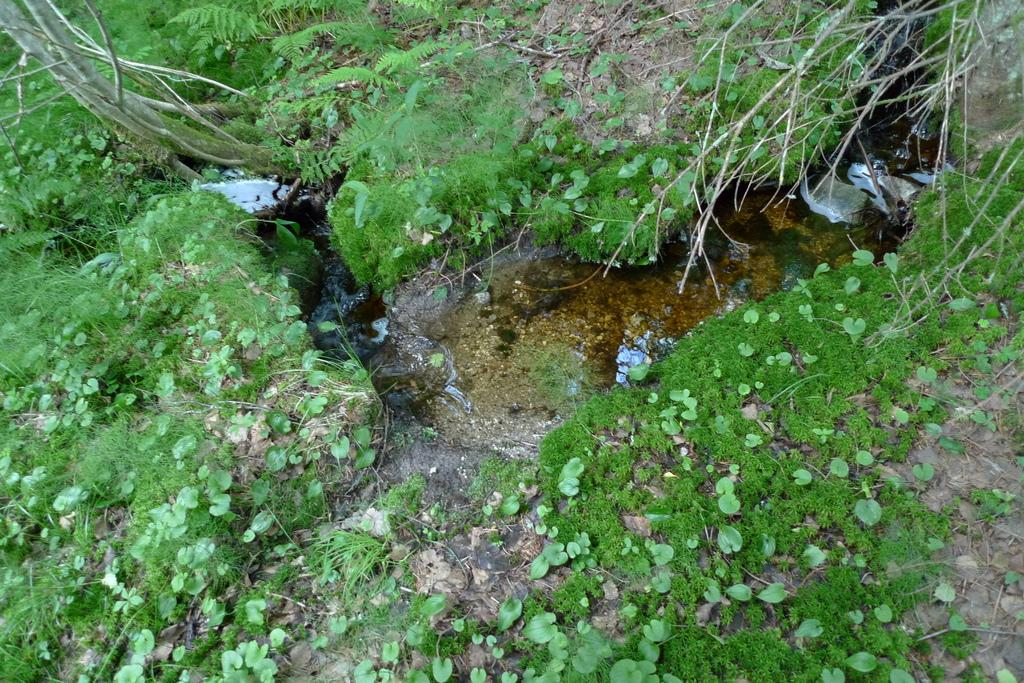What type of living organisms can be seen in the image? Plants can be seen in the image. What is visible on the ground in the image? There is water on the ground in the image. What type of suit is the plant wearing in the image? There is no suit present in the image, as plants do not wear clothing. 